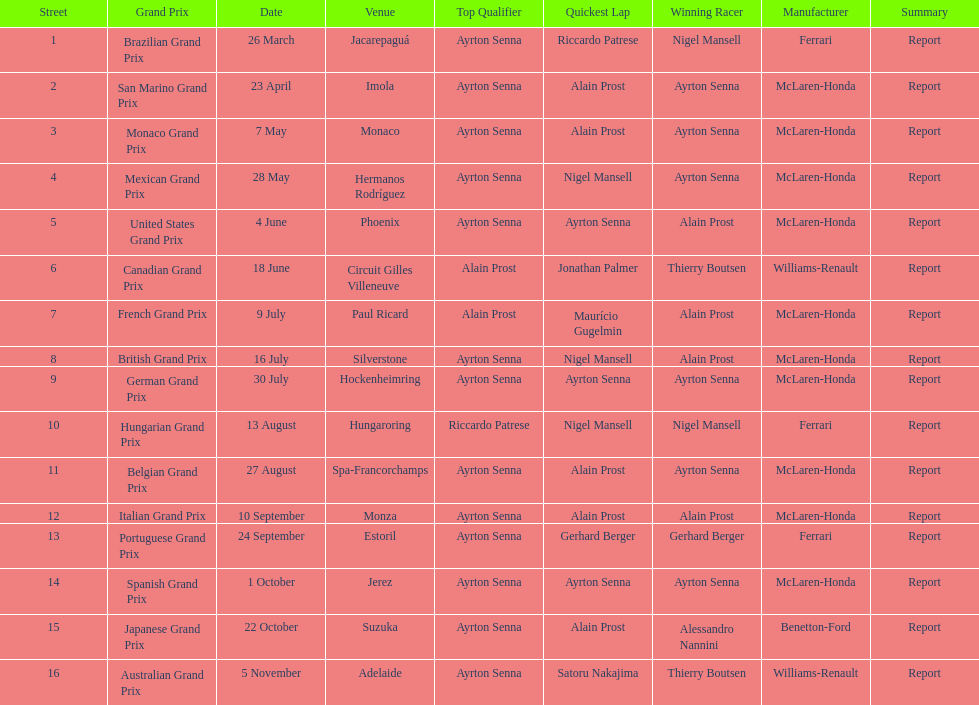Who had the fastest lap at the german grand prix? Ayrton Senna. 